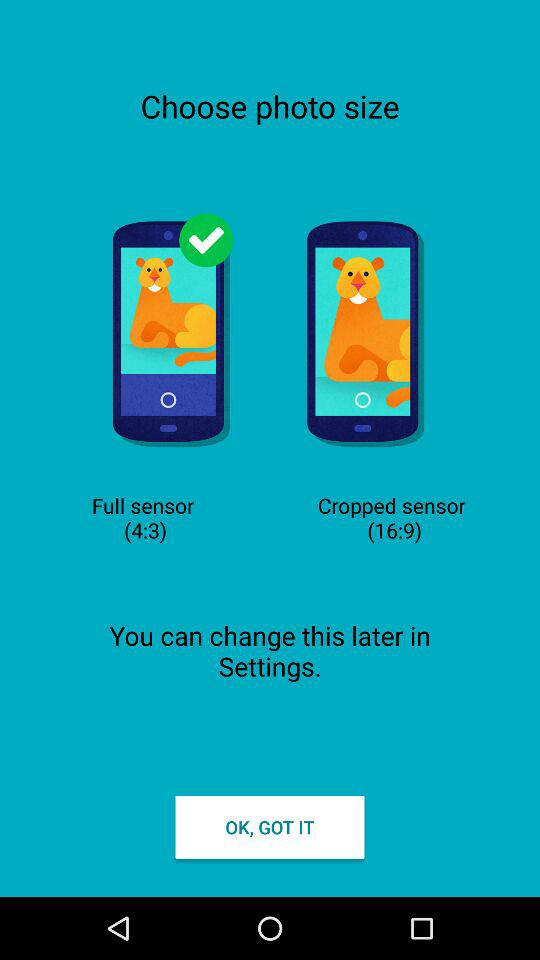How many photo sizes are available?
Answer the question using a single word or phrase. 2 